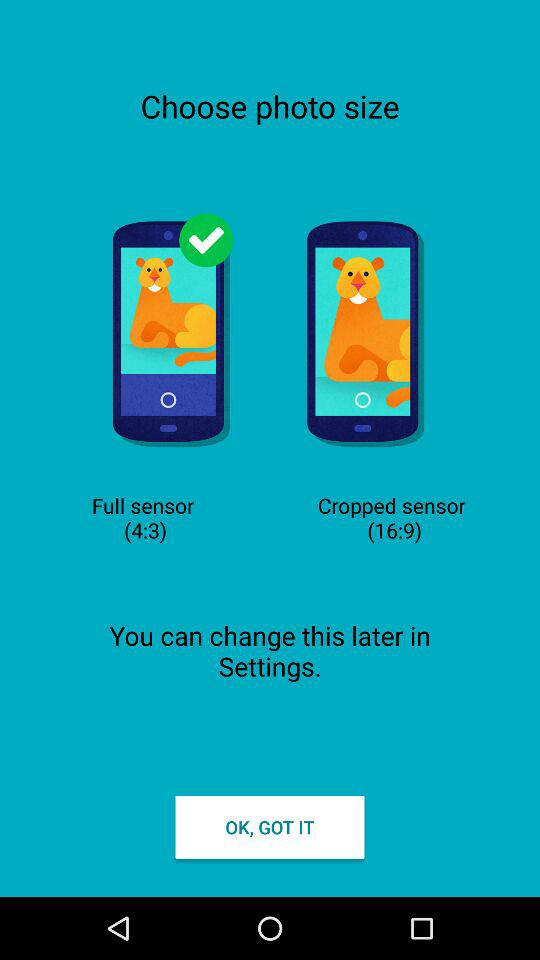How many photo sizes are available?
Answer the question using a single word or phrase. 2 